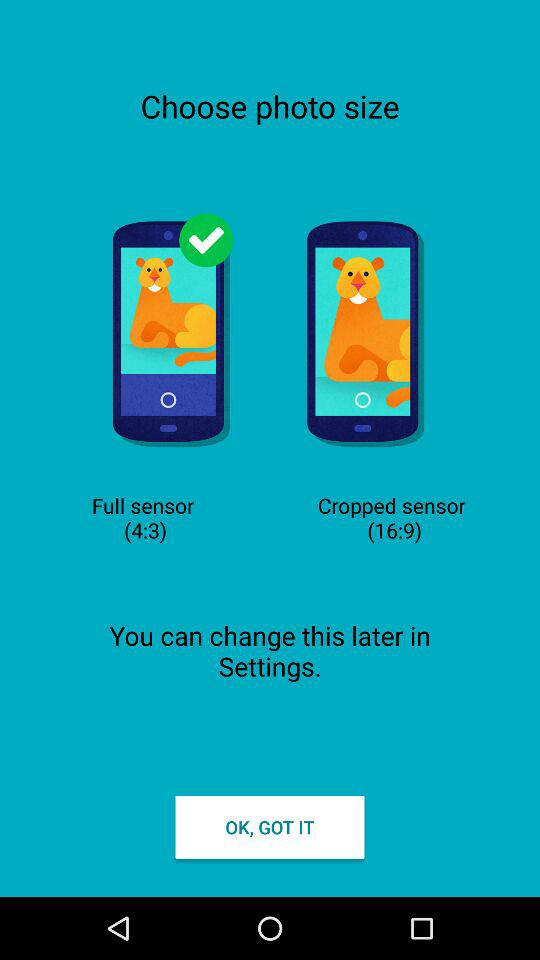How many photo sizes are available?
Answer the question using a single word or phrase. 2 